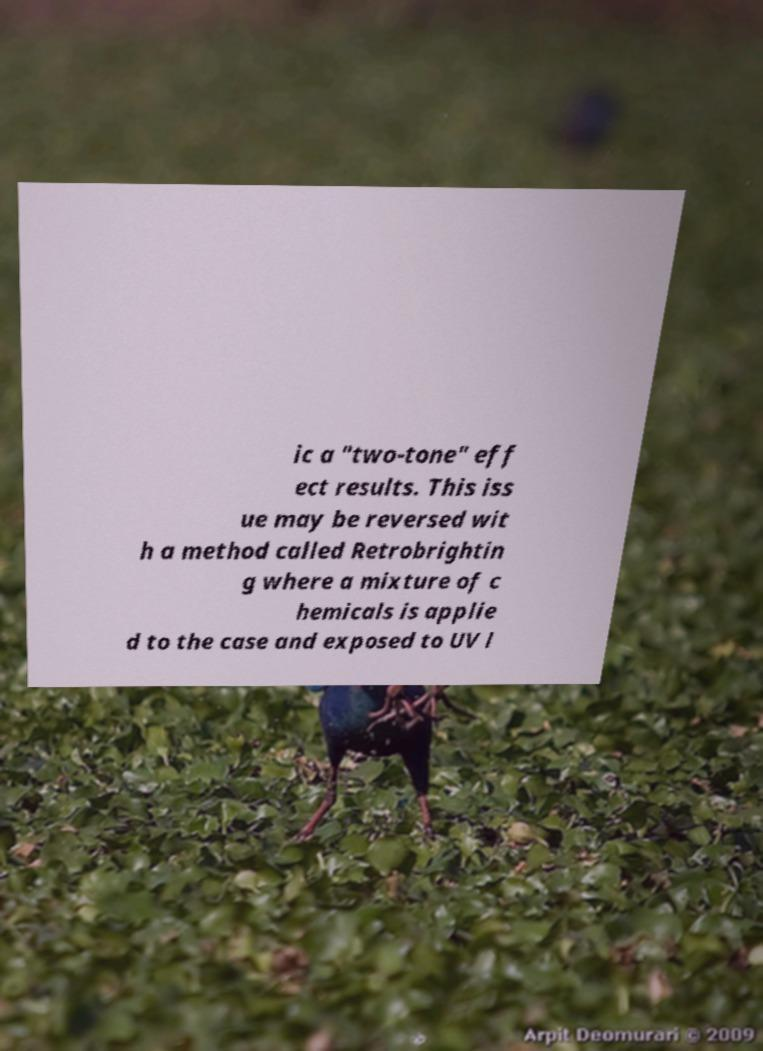Could you assist in decoding the text presented in this image and type it out clearly? ic a "two-tone" eff ect results. This iss ue may be reversed wit h a method called Retrobrightin g where a mixture of c hemicals is applie d to the case and exposed to UV l 